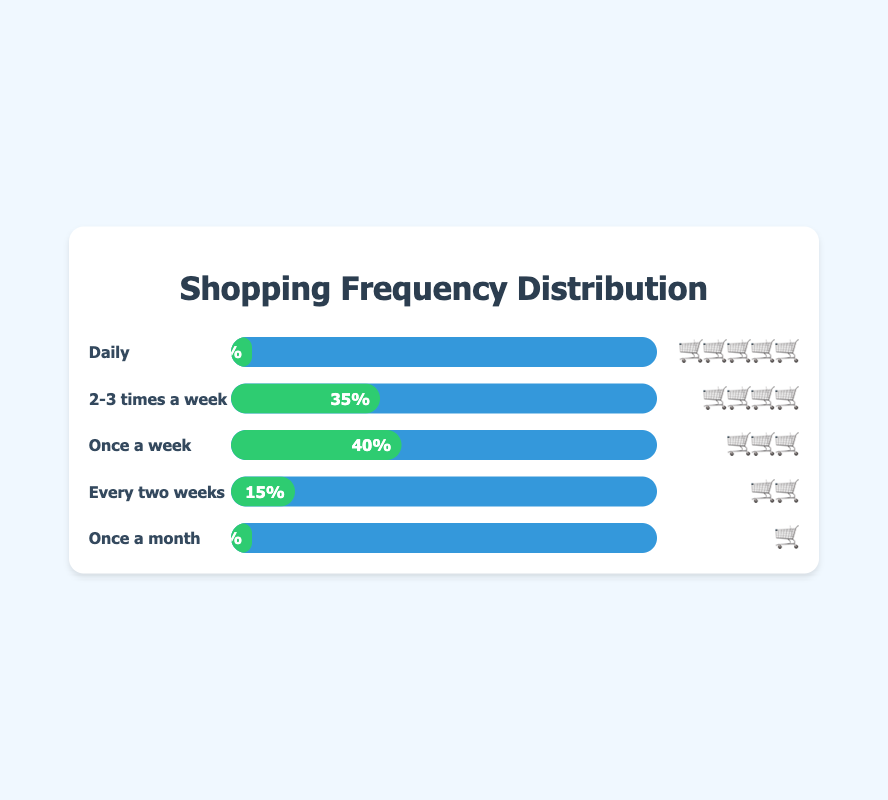What is the title of the chart? The title of the chart is prominently displayed at the top of the figure in a larger font. It provides a summary of what the chart represents.
Answer: Shopping Frequency Distribution Which shopping frequency has the highest percentage? By examining the chart, the bar with the longest width or the highest percentage label represents the highest percentage.
Answer: Once a week What percentage of customers shop daily? Look at the section labeled "Daily" and check the percentage displayed within the green bar.
Answer: 5% Which two frequencies have equal percentages? Compare lengths and percentages of all bars to find any two with the same value.
Answer: Daily and Once a month How many times a week do most customers shop? Identify the bar with the highest percentage and refer to its corresponding frequency, then translate that frequency into a weekly context.
Answer: Once a week What is the overall percentage of customers who shop more than once a week? Sum the percentages of frequencies that occur more than once a week: "Daily" and "2-3 times a week". 5% + 35% = 40%.
Answer: 40% Calculate the difference in percentage between the most frequent and least frequent shopping habits? Subtract the percentage of the least frequent habit ("Once a month", 5%) from the most frequent habit ("Once a week", 40%). 40% - 5% = 35%.
Answer: 35% How do the indicators for "Every two weeks" and "Once a month" compare in terms of emoji representation? Look at the emojis next to "Every two weeks" and "Once a month" and compare the symbols visually.
Answer: 🛒🛒 vs 🛒 